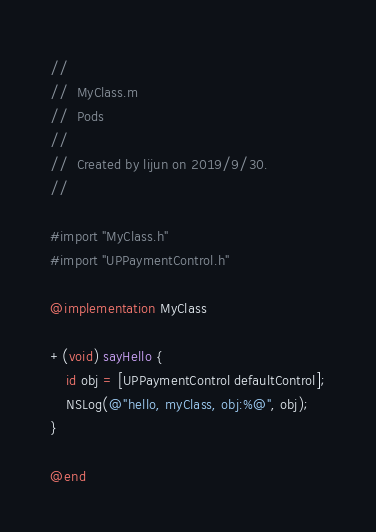Convert code to text. <code><loc_0><loc_0><loc_500><loc_500><_ObjectiveC_>//
//  MyClass.m
//  Pods
//
//  Created by lijun on 2019/9/30.
//

#import "MyClass.h"
#import "UPPaymentControl.h"

@implementation MyClass

+(void) sayHello {
    id obj = [UPPaymentControl defaultControl];
    NSLog(@"hello, myClass, obj:%@", obj);
}

@end
</code> 